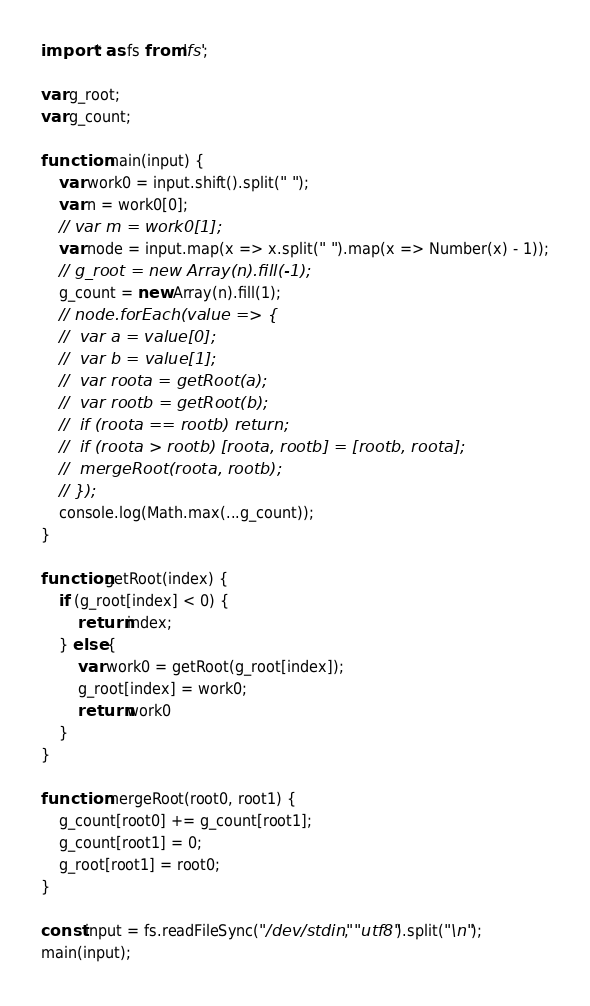Convert code to text. <code><loc_0><loc_0><loc_500><loc_500><_TypeScript_>import * as fs from 'fs';

var g_root;
var g_count;

function main(input) {
	var work0 = input.shift().split(" ");
	var n = work0[0];
	// var m = work0[1];
	var node = input.map(x => x.split(" ").map(x => Number(x) - 1));
	// g_root = new Array(n).fill(-1);
	g_count = new Array(n).fill(1);
	// node.forEach(value => {
	// 	var a = value[0];
	// 	var b = value[1];
	// 	var roota = getRoot(a);
	// 	var rootb = getRoot(b);
	// 	if (roota == rootb) return;
	// 	if (roota > rootb) [roota, rootb] = [rootb, roota];
	// 	mergeRoot(roota, rootb);
	// });
	console.log(Math.max(...g_count));
}

function getRoot(index) {
	if (g_root[index] < 0) {
		return index;
	} else {
		var work0 = getRoot(g_root[index]);
		g_root[index] = work0;
		return work0
	}
}

function mergeRoot(root0, root1) {
	g_count[root0] += g_count[root1];
	g_count[root1] = 0;
	g_root[root1] = root0;
}

const input = fs.readFileSync("/dev/stdin", "utf8").split("\n");
main(input);
</code> 